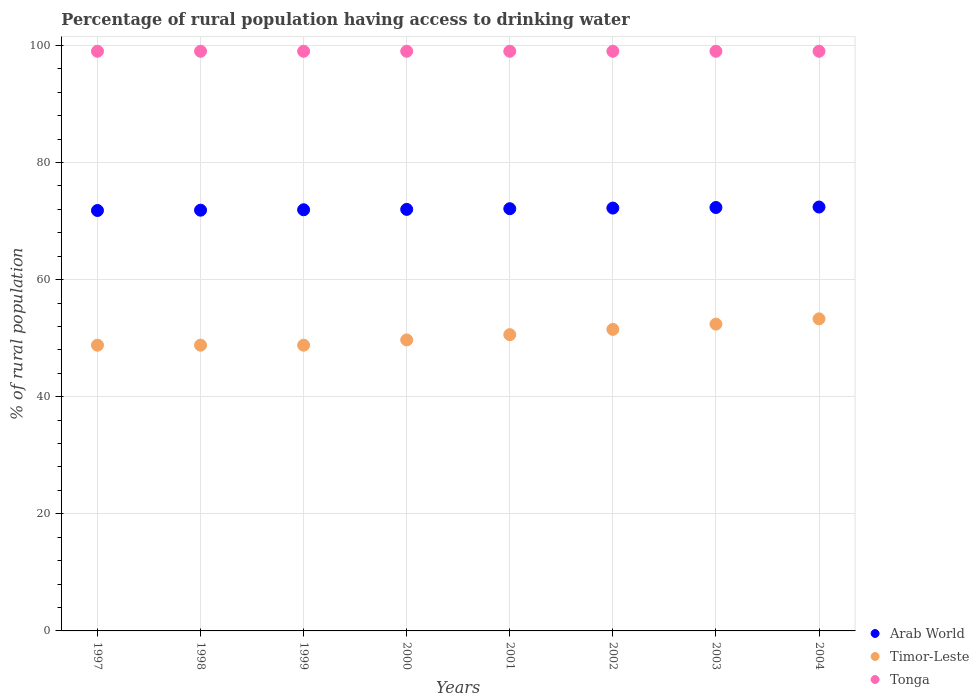What is the percentage of rural population having access to drinking water in Tonga in 2004?
Make the answer very short. 99. Across all years, what is the maximum percentage of rural population having access to drinking water in Arab World?
Ensure brevity in your answer.  72.4. Across all years, what is the minimum percentage of rural population having access to drinking water in Arab World?
Your answer should be very brief. 71.81. What is the total percentage of rural population having access to drinking water in Timor-Leste in the graph?
Keep it short and to the point. 403.9. What is the difference between the percentage of rural population having access to drinking water in Timor-Leste in 1997 and that in 2003?
Your answer should be compact. -3.6. What is the difference between the percentage of rural population having access to drinking water in Timor-Leste in 2004 and the percentage of rural population having access to drinking water in Arab World in 2001?
Provide a succinct answer. -18.81. What is the average percentage of rural population having access to drinking water in Timor-Leste per year?
Offer a terse response. 50.49. In the year 1998, what is the difference between the percentage of rural population having access to drinking water in Timor-Leste and percentage of rural population having access to drinking water in Arab World?
Make the answer very short. -23.06. What is the ratio of the percentage of rural population having access to drinking water in Arab World in 2000 to that in 2003?
Your answer should be compact. 1. Is the percentage of rural population having access to drinking water in Arab World in 2002 less than that in 2004?
Provide a succinct answer. Yes. What is the difference between the highest and the second highest percentage of rural population having access to drinking water in Timor-Leste?
Ensure brevity in your answer.  0.9. What is the difference between the highest and the lowest percentage of rural population having access to drinking water in Arab World?
Make the answer very short. 0.59. In how many years, is the percentage of rural population having access to drinking water in Timor-Leste greater than the average percentage of rural population having access to drinking water in Timor-Leste taken over all years?
Make the answer very short. 4. Is the percentage of rural population having access to drinking water in Tonga strictly greater than the percentage of rural population having access to drinking water in Timor-Leste over the years?
Your answer should be compact. Yes. How many dotlines are there?
Keep it short and to the point. 3. What is the difference between two consecutive major ticks on the Y-axis?
Give a very brief answer. 20. Are the values on the major ticks of Y-axis written in scientific E-notation?
Your answer should be very brief. No. Does the graph contain any zero values?
Your answer should be compact. No. What is the title of the graph?
Offer a very short reply. Percentage of rural population having access to drinking water. What is the label or title of the Y-axis?
Offer a very short reply. % of rural population. What is the % of rural population in Arab World in 1997?
Your answer should be compact. 71.81. What is the % of rural population of Timor-Leste in 1997?
Your answer should be compact. 48.8. What is the % of rural population in Arab World in 1998?
Keep it short and to the point. 71.86. What is the % of rural population of Timor-Leste in 1998?
Your answer should be very brief. 48.8. What is the % of rural population in Tonga in 1998?
Your response must be concise. 99. What is the % of rural population of Arab World in 1999?
Provide a succinct answer. 71.93. What is the % of rural population of Timor-Leste in 1999?
Offer a terse response. 48.8. What is the % of rural population in Tonga in 1999?
Give a very brief answer. 99. What is the % of rural population in Arab World in 2000?
Your answer should be compact. 72. What is the % of rural population of Timor-Leste in 2000?
Keep it short and to the point. 49.7. What is the % of rural population of Arab World in 2001?
Your response must be concise. 72.11. What is the % of rural population in Timor-Leste in 2001?
Keep it short and to the point. 50.6. What is the % of rural population in Tonga in 2001?
Ensure brevity in your answer.  99. What is the % of rural population of Arab World in 2002?
Offer a very short reply. 72.22. What is the % of rural population of Timor-Leste in 2002?
Your response must be concise. 51.5. What is the % of rural population of Arab World in 2003?
Offer a terse response. 72.32. What is the % of rural population of Timor-Leste in 2003?
Give a very brief answer. 52.4. What is the % of rural population of Arab World in 2004?
Offer a terse response. 72.4. What is the % of rural population in Timor-Leste in 2004?
Your answer should be very brief. 53.3. What is the % of rural population of Tonga in 2004?
Make the answer very short. 99. Across all years, what is the maximum % of rural population in Arab World?
Ensure brevity in your answer.  72.4. Across all years, what is the maximum % of rural population of Timor-Leste?
Provide a succinct answer. 53.3. Across all years, what is the minimum % of rural population in Arab World?
Ensure brevity in your answer.  71.81. Across all years, what is the minimum % of rural population of Timor-Leste?
Your answer should be compact. 48.8. What is the total % of rural population of Arab World in the graph?
Ensure brevity in your answer.  576.64. What is the total % of rural population of Timor-Leste in the graph?
Your response must be concise. 403.9. What is the total % of rural population in Tonga in the graph?
Offer a very short reply. 792. What is the difference between the % of rural population in Arab World in 1997 and that in 1998?
Your response must be concise. -0.05. What is the difference between the % of rural population in Tonga in 1997 and that in 1998?
Keep it short and to the point. 0. What is the difference between the % of rural population in Arab World in 1997 and that in 1999?
Provide a succinct answer. -0.12. What is the difference between the % of rural population in Arab World in 1997 and that in 2000?
Give a very brief answer. -0.19. What is the difference between the % of rural population in Timor-Leste in 1997 and that in 2000?
Make the answer very short. -0.9. What is the difference between the % of rural population of Tonga in 1997 and that in 2000?
Offer a terse response. 0. What is the difference between the % of rural population of Arab World in 1997 and that in 2001?
Offer a very short reply. -0.31. What is the difference between the % of rural population of Tonga in 1997 and that in 2001?
Offer a terse response. 0. What is the difference between the % of rural population of Arab World in 1997 and that in 2002?
Your answer should be very brief. -0.42. What is the difference between the % of rural population in Timor-Leste in 1997 and that in 2002?
Make the answer very short. -2.7. What is the difference between the % of rural population of Tonga in 1997 and that in 2002?
Provide a short and direct response. 0. What is the difference between the % of rural population of Arab World in 1997 and that in 2003?
Give a very brief answer. -0.51. What is the difference between the % of rural population in Timor-Leste in 1997 and that in 2003?
Provide a succinct answer. -3.6. What is the difference between the % of rural population in Arab World in 1997 and that in 2004?
Provide a short and direct response. -0.59. What is the difference between the % of rural population in Timor-Leste in 1997 and that in 2004?
Make the answer very short. -4.5. What is the difference between the % of rural population in Tonga in 1997 and that in 2004?
Make the answer very short. 0. What is the difference between the % of rural population in Arab World in 1998 and that in 1999?
Provide a succinct answer. -0.07. What is the difference between the % of rural population of Tonga in 1998 and that in 1999?
Offer a very short reply. 0. What is the difference between the % of rural population in Arab World in 1998 and that in 2000?
Your response must be concise. -0.14. What is the difference between the % of rural population in Tonga in 1998 and that in 2000?
Give a very brief answer. 0. What is the difference between the % of rural population in Arab World in 1998 and that in 2001?
Give a very brief answer. -0.25. What is the difference between the % of rural population of Timor-Leste in 1998 and that in 2001?
Provide a short and direct response. -1.8. What is the difference between the % of rural population of Tonga in 1998 and that in 2001?
Ensure brevity in your answer.  0. What is the difference between the % of rural population of Arab World in 1998 and that in 2002?
Offer a terse response. -0.36. What is the difference between the % of rural population in Arab World in 1998 and that in 2003?
Make the answer very short. -0.46. What is the difference between the % of rural population in Timor-Leste in 1998 and that in 2003?
Offer a very short reply. -3.6. What is the difference between the % of rural population of Arab World in 1998 and that in 2004?
Your answer should be very brief. -0.54. What is the difference between the % of rural population of Tonga in 1998 and that in 2004?
Offer a very short reply. 0. What is the difference between the % of rural population of Arab World in 1999 and that in 2000?
Your answer should be compact. -0.07. What is the difference between the % of rural population in Timor-Leste in 1999 and that in 2000?
Your response must be concise. -0.9. What is the difference between the % of rural population of Arab World in 1999 and that in 2001?
Your answer should be compact. -0.18. What is the difference between the % of rural population of Timor-Leste in 1999 and that in 2001?
Offer a terse response. -1.8. What is the difference between the % of rural population in Tonga in 1999 and that in 2001?
Your response must be concise. 0. What is the difference between the % of rural population in Arab World in 1999 and that in 2002?
Provide a short and direct response. -0.29. What is the difference between the % of rural population of Arab World in 1999 and that in 2003?
Your answer should be compact. -0.39. What is the difference between the % of rural population of Timor-Leste in 1999 and that in 2003?
Your response must be concise. -3.6. What is the difference between the % of rural population in Arab World in 1999 and that in 2004?
Ensure brevity in your answer.  -0.47. What is the difference between the % of rural population of Arab World in 2000 and that in 2001?
Provide a succinct answer. -0.12. What is the difference between the % of rural population in Tonga in 2000 and that in 2001?
Your answer should be compact. 0. What is the difference between the % of rural population in Arab World in 2000 and that in 2002?
Offer a terse response. -0.23. What is the difference between the % of rural population of Tonga in 2000 and that in 2002?
Your answer should be very brief. 0. What is the difference between the % of rural population of Arab World in 2000 and that in 2003?
Keep it short and to the point. -0.32. What is the difference between the % of rural population of Timor-Leste in 2000 and that in 2003?
Your answer should be compact. -2.7. What is the difference between the % of rural population of Tonga in 2000 and that in 2003?
Your response must be concise. 0. What is the difference between the % of rural population of Arab World in 2000 and that in 2004?
Offer a terse response. -0.4. What is the difference between the % of rural population in Timor-Leste in 2000 and that in 2004?
Provide a short and direct response. -3.6. What is the difference between the % of rural population in Arab World in 2001 and that in 2002?
Your response must be concise. -0.11. What is the difference between the % of rural population in Timor-Leste in 2001 and that in 2002?
Give a very brief answer. -0.9. What is the difference between the % of rural population of Arab World in 2001 and that in 2003?
Your response must be concise. -0.21. What is the difference between the % of rural population of Timor-Leste in 2001 and that in 2003?
Keep it short and to the point. -1.8. What is the difference between the % of rural population of Tonga in 2001 and that in 2003?
Keep it short and to the point. 0. What is the difference between the % of rural population in Arab World in 2001 and that in 2004?
Your answer should be compact. -0.29. What is the difference between the % of rural population in Timor-Leste in 2001 and that in 2004?
Give a very brief answer. -2.7. What is the difference between the % of rural population in Arab World in 2002 and that in 2003?
Offer a very short reply. -0.1. What is the difference between the % of rural population of Timor-Leste in 2002 and that in 2003?
Make the answer very short. -0.9. What is the difference between the % of rural population of Arab World in 2002 and that in 2004?
Offer a terse response. -0.18. What is the difference between the % of rural population in Timor-Leste in 2002 and that in 2004?
Your answer should be very brief. -1.8. What is the difference between the % of rural population in Arab World in 2003 and that in 2004?
Give a very brief answer. -0.08. What is the difference between the % of rural population of Timor-Leste in 2003 and that in 2004?
Offer a very short reply. -0.9. What is the difference between the % of rural population in Arab World in 1997 and the % of rural population in Timor-Leste in 1998?
Your answer should be compact. 23.01. What is the difference between the % of rural population in Arab World in 1997 and the % of rural population in Tonga in 1998?
Your answer should be compact. -27.19. What is the difference between the % of rural population of Timor-Leste in 1997 and the % of rural population of Tonga in 1998?
Keep it short and to the point. -50.2. What is the difference between the % of rural population of Arab World in 1997 and the % of rural population of Timor-Leste in 1999?
Ensure brevity in your answer.  23.01. What is the difference between the % of rural population of Arab World in 1997 and the % of rural population of Tonga in 1999?
Your answer should be very brief. -27.19. What is the difference between the % of rural population of Timor-Leste in 1997 and the % of rural population of Tonga in 1999?
Give a very brief answer. -50.2. What is the difference between the % of rural population of Arab World in 1997 and the % of rural population of Timor-Leste in 2000?
Your answer should be compact. 22.11. What is the difference between the % of rural population in Arab World in 1997 and the % of rural population in Tonga in 2000?
Your response must be concise. -27.19. What is the difference between the % of rural population of Timor-Leste in 1997 and the % of rural population of Tonga in 2000?
Give a very brief answer. -50.2. What is the difference between the % of rural population in Arab World in 1997 and the % of rural population in Timor-Leste in 2001?
Provide a short and direct response. 21.21. What is the difference between the % of rural population of Arab World in 1997 and the % of rural population of Tonga in 2001?
Offer a very short reply. -27.19. What is the difference between the % of rural population in Timor-Leste in 1997 and the % of rural population in Tonga in 2001?
Make the answer very short. -50.2. What is the difference between the % of rural population in Arab World in 1997 and the % of rural population in Timor-Leste in 2002?
Provide a short and direct response. 20.31. What is the difference between the % of rural population of Arab World in 1997 and the % of rural population of Tonga in 2002?
Keep it short and to the point. -27.19. What is the difference between the % of rural population of Timor-Leste in 1997 and the % of rural population of Tonga in 2002?
Your response must be concise. -50.2. What is the difference between the % of rural population of Arab World in 1997 and the % of rural population of Timor-Leste in 2003?
Offer a very short reply. 19.41. What is the difference between the % of rural population of Arab World in 1997 and the % of rural population of Tonga in 2003?
Keep it short and to the point. -27.19. What is the difference between the % of rural population in Timor-Leste in 1997 and the % of rural population in Tonga in 2003?
Offer a terse response. -50.2. What is the difference between the % of rural population of Arab World in 1997 and the % of rural population of Timor-Leste in 2004?
Give a very brief answer. 18.51. What is the difference between the % of rural population in Arab World in 1997 and the % of rural population in Tonga in 2004?
Offer a very short reply. -27.19. What is the difference between the % of rural population in Timor-Leste in 1997 and the % of rural population in Tonga in 2004?
Your answer should be compact. -50.2. What is the difference between the % of rural population of Arab World in 1998 and the % of rural population of Timor-Leste in 1999?
Provide a short and direct response. 23.06. What is the difference between the % of rural population of Arab World in 1998 and the % of rural population of Tonga in 1999?
Your answer should be compact. -27.14. What is the difference between the % of rural population of Timor-Leste in 1998 and the % of rural population of Tonga in 1999?
Provide a succinct answer. -50.2. What is the difference between the % of rural population of Arab World in 1998 and the % of rural population of Timor-Leste in 2000?
Your answer should be very brief. 22.16. What is the difference between the % of rural population in Arab World in 1998 and the % of rural population in Tonga in 2000?
Give a very brief answer. -27.14. What is the difference between the % of rural population of Timor-Leste in 1998 and the % of rural population of Tonga in 2000?
Provide a succinct answer. -50.2. What is the difference between the % of rural population in Arab World in 1998 and the % of rural population in Timor-Leste in 2001?
Ensure brevity in your answer.  21.26. What is the difference between the % of rural population in Arab World in 1998 and the % of rural population in Tonga in 2001?
Ensure brevity in your answer.  -27.14. What is the difference between the % of rural population in Timor-Leste in 1998 and the % of rural population in Tonga in 2001?
Ensure brevity in your answer.  -50.2. What is the difference between the % of rural population of Arab World in 1998 and the % of rural population of Timor-Leste in 2002?
Ensure brevity in your answer.  20.36. What is the difference between the % of rural population of Arab World in 1998 and the % of rural population of Tonga in 2002?
Offer a terse response. -27.14. What is the difference between the % of rural population in Timor-Leste in 1998 and the % of rural population in Tonga in 2002?
Your response must be concise. -50.2. What is the difference between the % of rural population in Arab World in 1998 and the % of rural population in Timor-Leste in 2003?
Your answer should be very brief. 19.46. What is the difference between the % of rural population in Arab World in 1998 and the % of rural population in Tonga in 2003?
Provide a short and direct response. -27.14. What is the difference between the % of rural population of Timor-Leste in 1998 and the % of rural population of Tonga in 2003?
Provide a short and direct response. -50.2. What is the difference between the % of rural population in Arab World in 1998 and the % of rural population in Timor-Leste in 2004?
Provide a succinct answer. 18.56. What is the difference between the % of rural population in Arab World in 1998 and the % of rural population in Tonga in 2004?
Offer a terse response. -27.14. What is the difference between the % of rural population in Timor-Leste in 1998 and the % of rural population in Tonga in 2004?
Provide a succinct answer. -50.2. What is the difference between the % of rural population of Arab World in 1999 and the % of rural population of Timor-Leste in 2000?
Make the answer very short. 22.23. What is the difference between the % of rural population in Arab World in 1999 and the % of rural population in Tonga in 2000?
Make the answer very short. -27.07. What is the difference between the % of rural population in Timor-Leste in 1999 and the % of rural population in Tonga in 2000?
Provide a short and direct response. -50.2. What is the difference between the % of rural population of Arab World in 1999 and the % of rural population of Timor-Leste in 2001?
Keep it short and to the point. 21.33. What is the difference between the % of rural population of Arab World in 1999 and the % of rural population of Tonga in 2001?
Make the answer very short. -27.07. What is the difference between the % of rural population in Timor-Leste in 1999 and the % of rural population in Tonga in 2001?
Offer a terse response. -50.2. What is the difference between the % of rural population in Arab World in 1999 and the % of rural population in Timor-Leste in 2002?
Your response must be concise. 20.43. What is the difference between the % of rural population of Arab World in 1999 and the % of rural population of Tonga in 2002?
Provide a short and direct response. -27.07. What is the difference between the % of rural population of Timor-Leste in 1999 and the % of rural population of Tonga in 2002?
Offer a very short reply. -50.2. What is the difference between the % of rural population of Arab World in 1999 and the % of rural population of Timor-Leste in 2003?
Offer a terse response. 19.53. What is the difference between the % of rural population in Arab World in 1999 and the % of rural population in Tonga in 2003?
Make the answer very short. -27.07. What is the difference between the % of rural population of Timor-Leste in 1999 and the % of rural population of Tonga in 2003?
Your answer should be compact. -50.2. What is the difference between the % of rural population of Arab World in 1999 and the % of rural population of Timor-Leste in 2004?
Your response must be concise. 18.63. What is the difference between the % of rural population of Arab World in 1999 and the % of rural population of Tonga in 2004?
Your response must be concise. -27.07. What is the difference between the % of rural population of Timor-Leste in 1999 and the % of rural population of Tonga in 2004?
Give a very brief answer. -50.2. What is the difference between the % of rural population in Arab World in 2000 and the % of rural population in Timor-Leste in 2001?
Offer a very short reply. 21.4. What is the difference between the % of rural population of Arab World in 2000 and the % of rural population of Tonga in 2001?
Ensure brevity in your answer.  -27. What is the difference between the % of rural population in Timor-Leste in 2000 and the % of rural population in Tonga in 2001?
Make the answer very short. -49.3. What is the difference between the % of rural population of Arab World in 2000 and the % of rural population of Timor-Leste in 2002?
Offer a terse response. 20.5. What is the difference between the % of rural population of Arab World in 2000 and the % of rural population of Tonga in 2002?
Make the answer very short. -27. What is the difference between the % of rural population of Timor-Leste in 2000 and the % of rural population of Tonga in 2002?
Offer a terse response. -49.3. What is the difference between the % of rural population in Arab World in 2000 and the % of rural population in Timor-Leste in 2003?
Keep it short and to the point. 19.6. What is the difference between the % of rural population of Arab World in 2000 and the % of rural population of Tonga in 2003?
Your response must be concise. -27. What is the difference between the % of rural population of Timor-Leste in 2000 and the % of rural population of Tonga in 2003?
Your response must be concise. -49.3. What is the difference between the % of rural population in Arab World in 2000 and the % of rural population in Timor-Leste in 2004?
Make the answer very short. 18.7. What is the difference between the % of rural population in Arab World in 2000 and the % of rural population in Tonga in 2004?
Ensure brevity in your answer.  -27. What is the difference between the % of rural population in Timor-Leste in 2000 and the % of rural population in Tonga in 2004?
Offer a very short reply. -49.3. What is the difference between the % of rural population of Arab World in 2001 and the % of rural population of Timor-Leste in 2002?
Give a very brief answer. 20.61. What is the difference between the % of rural population of Arab World in 2001 and the % of rural population of Tonga in 2002?
Keep it short and to the point. -26.89. What is the difference between the % of rural population in Timor-Leste in 2001 and the % of rural population in Tonga in 2002?
Offer a terse response. -48.4. What is the difference between the % of rural population of Arab World in 2001 and the % of rural population of Timor-Leste in 2003?
Keep it short and to the point. 19.71. What is the difference between the % of rural population of Arab World in 2001 and the % of rural population of Tonga in 2003?
Provide a short and direct response. -26.89. What is the difference between the % of rural population in Timor-Leste in 2001 and the % of rural population in Tonga in 2003?
Your answer should be compact. -48.4. What is the difference between the % of rural population in Arab World in 2001 and the % of rural population in Timor-Leste in 2004?
Offer a very short reply. 18.81. What is the difference between the % of rural population in Arab World in 2001 and the % of rural population in Tonga in 2004?
Ensure brevity in your answer.  -26.89. What is the difference between the % of rural population in Timor-Leste in 2001 and the % of rural population in Tonga in 2004?
Your answer should be compact. -48.4. What is the difference between the % of rural population of Arab World in 2002 and the % of rural population of Timor-Leste in 2003?
Give a very brief answer. 19.82. What is the difference between the % of rural population of Arab World in 2002 and the % of rural population of Tonga in 2003?
Keep it short and to the point. -26.78. What is the difference between the % of rural population of Timor-Leste in 2002 and the % of rural population of Tonga in 2003?
Make the answer very short. -47.5. What is the difference between the % of rural population in Arab World in 2002 and the % of rural population in Timor-Leste in 2004?
Offer a very short reply. 18.92. What is the difference between the % of rural population in Arab World in 2002 and the % of rural population in Tonga in 2004?
Keep it short and to the point. -26.78. What is the difference between the % of rural population of Timor-Leste in 2002 and the % of rural population of Tonga in 2004?
Offer a terse response. -47.5. What is the difference between the % of rural population of Arab World in 2003 and the % of rural population of Timor-Leste in 2004?
Offer a very short reply. 19.02. What is the difference between the % of rural population in Arab World in 2003 and the % of rural population in Tonga in 2004?
Your response must be concise. -26.68. What is the difference between the % of rural population of Timor-Leste in 2003 and the % of rural population of Tonga in 2004?
Give a very brief answer. -46.6. What is the average % of rural population of Arab World per year?
Make the answer very short. 72.08. What is the average % of rural population in Timor-Leste per year?
Your answer should be compact. 50.49. In the year 1997, what is the difference between the % of rural population of Arab World and % of rural population of Timor-Leste?
Your answer should be very brief. 23.01. In the year 1997, what is the difference between the % of rural population in Arab World and % of rural population in Tonga?
Keep it short and to the point. -27.19. In the year 1997, what is the difference between the % of rural population in Timor-Leste and % of rural population in Tonga?
Your answer should be compact. -50.2. In the year 1998, what is the difference between the % of rural population of Arab World and % of rural population of Timor-Leste?
Keep it short and to the point. 23.06. In the year 1998, what is the difference between the % of rural population of Arab World and % of rural population of Tonga?
Make the answer very short. -27.14. In the year 1998, what is the difference between the % of rural population in Timor-Leste and % of rural population in Tonga?
Keep it short and to the point. -50.2. In the year 1999, what is the difference between the % of rural population in Arab World and % of rural population in Timor-Leste?
Offer a very short reply. 23.13. In the year 1999, what is the difference between the % of rural population in Arab World and % of rural population in Tonga?
Give a very brief answer. -27.07. In the year 1999, what is the difference between the % of rural population of Timor-Leste and % of rural population of Tonga?
Make the answer very short. -50.2. In the year 2000, what is the difference between the % of rural population of Arab World and % of rural population of Timor-Leste?
Keep it short and to the point. 22.3. In the year 2000, what is the difference between the % of rural population in Arab World and % of rural population in Tonga?
Provide a short and direct response. -27. In the year 2000, what is the difference between the % of rural population in Timor-Leste and % of rural population in Tonga?
Offer a terse response. -49.3. In the year 2001, what is the difference between the % of rural population of Arab World and % of rural population of Timor-Leste?
Offer a terse response. 21.51. In the year 2001, what is the difference between the % of rural population in Arab World and % of rural population in Tonga?
Provide a succinct answer. -26.89. In the year 2001, what is the difference between the % of rural population of Timor-Leste and % of rural population of Tonga?
Offer a terse response. -48.4. In the year 2002, what is the difference between the % of rural population in Arab World and % of rural population in Timor-Leste?
Give a very brief answer. 20.72. In the year 2002, what is the difference between the % of rural population of Arab World and % of rural population of Tonga?
Your answer should be very brief. -26.78. In the year 2002, what is the difference between the % of rural population of Timor-Leste and % of rural population of Tonga?
Provide a short and direct response. -47.5. In the year 2003, what is the difference between the % of rural population in Arab World and % of rural population in Timor-Leste?
Your response must be concise. 19.92. In the year 2003, what is the difference between the % of rural population in Arab World and % of rural population in Tonga?
Keep it short and to the point. -26.68. In the year 2003, what is the difference between the % of rural population of Timor-Leste and % of rural population of Tonga?
Offer a terse response. -46.6. In the year 2004, what is the difference between the % of rural population of Arab World and % of rural population of Timor-Leste?
Offer a terse response. 19.1. In the year 2004, what is the difference between the % of rural population in Arab World and % of rural population in Tonga?
Ensure brevity in your answer.  -26.6. In the year 2004, what is the difference between the % of rural population in Timor-Leste and % of rural population in Tonga?
Make the answer very short. -45.7. What is the ratio of the % of rural population in Arab World in 1997 to that in 1998?
Your response must be concise. 1. What is the ratio of the % of rural population of Timor-Leste in 1997 to that in 1998?
Give a very brief answer. 1. What is the ratio of the % of rural population of Timor-Leste in 1997 to that in 1999?
Make the answer very short. 1. What is the ratio of the % of rural population of Timor-Leste in 1997 to that in 2000?
Your answer should be very brief. 0.98. What is the ratio of the % of rural population of Timor-Leste in 1997 to that in 2001?
Your answer should be very brief. 0.96. What is the ratio of the % of rural population of Tonga in 1997 to that in 2001?
Your response must be concise. 1. What is the ratio of the % of rural population in Arab World in 1997 to that in 2002?
Your response must be concise. 0.99. What is the ratio of the % of rural population in Timor-Leste in 1997 to that in 2002?
Provide a succinct answer. 0.95. What is the ratio of the % of rural population of Arab World in 1997 to that in 2003?
Your answer should be very brief. 0.99. What is the ratio of the % of rural population in Timor-Leste in 1997 to that in 2003?
Ensure brevity in your answer.  0.93. What is the ratio of the % of rural population of Tonga in 1997 to that in 2003?
Provide a short and direct response. 1. What is the ratio of the % of rural population in Arab World in 1997 to that in 2004?
Make the answer very short. 0.99. What is the ratio of the % of rural population of Timor-Leste in 1997 to that in 2004?
Keep it short and to the point. 0.92. What is the ratio of the % of rural population in Arab World in 1998 to that in 1999?
Give a very brief answer. 1. What is the ratio of the % of rural population of Timor-Leste in 1998 to that in 1999?
Provide a succinct answer. 1. What is the ratio of the % of rural population of Timor-Leste in 1998 to that in 2000?
Keep it short and to the point. 0.98. What is the ratio of the % of rural population in Timor-Leste in 1998 to that in 2001?
Ensure brevity in your answer.  0.96. What is the ratio of the % of rural population of Tonga in 1998 to that in 2001?
Offer a terse response. 1. What is the ratio of the % of rural population of Timor-Leste in 1998 to that in 2002?
Keep it short and to the point. 0.95. What is the ratio of the % of rural population of Tonga in 1998 to that in 2002?
Your response must be concise. 1. What is the ratio of the % of rural population in Arab World in 1998 to that in 2003?
Give a very brief answer. 0.99. What is the ratio of the % of rural population in Timor-Leste in 1998 to that in 2003?
Your answer should be very brief. 0.93. What is the ratio of the % of rural population in Tonga in 1998 to that in 2003?
Give a very brief answer. 1. What is the ratio of the % of rural population in Arab World in 1998 to that in 2004?
Your answer should be compact. 0.99. What is the ratio of the % of rural population in Timor-Leste in 1998 to that in 2004?
Provide a succinct answer. 0.92. What is the ratio of the % of rural population of Tonga in 1998 to that in 2004?
Ensure brevity in your answer.  1. What is the ratio of the % of rural population in Timor-Leste in 1999 to that in 2000?
Keep it short and to the point. 0.98. What is the ratio of the % of rural population in Timor-Leste in 1999 to that in 2001?
Keep it short and to the point. 0.96. What is the ratio of the % of rural population in Timor-Leste in 1999 to that in 2002?
Provide a short and direct response. 0.95. What is the ratio of the % of rural population of Tonga in 1999 to that in 2002?
Keep it short and to the point. 1. What is the ratio of the % of rural population in Arab World in 1999 to that in 2003?
Make the answer very short. 0.99. What is the ratio of the % of rural population of Timor-Leste in 1999 to that in 2003?
Your response must be concise. 0.93. What is the ratio of the % of rural population of Tonga in 1999 to that in 2003?
Give a very brief answer. 1. What is the ratio of the % of rural population of Arab World in 1999 to that in 2004?
Make the answer very short. 0.99. What is the ratio of the % of rural population of Timor-Leste in 1999 to that in 2004?
Your answer should be compact. 0.92. What is the ratio of the % of rural population in Tonga in 1999 to that in 2004?
Your response must be concise. 1. What is the ratio of the % of rural population of Arab World in 2000 to that in 2001?
Ensure brevity in your answer.  1. What is the ratio of the % of rural population in Timor-Leste in 2000 to that in 2001?
Your answer should be very brief. 0.98. What is the ratio of the % of rural population of Arab World in 2000 to that in 2002?
Your answer should be very brief. 1. What is the ratio of the % of rural population of Tonga in 2000 to that in 2002?
Offer a terse response. 1. What is the ratio of the % of rural population of Arab World in 2000 to that in 2003?
Keep it short and to the point. 1. What is the ratio of the % of rural population in Timor-Leste in 2000 to that in 2003?
Your answer should be very brief. 0.95. What is the ratio of the % of rural population of Arab World in 2000 to that in 2004?
Your answer should be very brief. 0.99. What is the ratio of the % of rural population of Timor-Leste in 2000 to that in 2004?
Ensure brevity in your answer.  0.93. What is the ratio of the % of rural population of Tonga in 2000 to that in 2004?
Provide a succinct answer. 1. What is the ratio of the % of rural population in Timor-Leste in 2001 to that in 2002?
Your answer should be very brief. 0.98. What is the ratio of the % of rural population in Arab World in 2001 to that in 2003?
Provide a short and direct response. 1. What is the ratio of the % of rural population of Timor-Leste in 2001 to that in 2003?
Keep it short and to the point. 0.97. What is the ratio of the % of rural population in Arab World in 2001 to that in 2004?
Keep it short and to the point. 1. What is the ratio of the % of rural population in Timor-Leste in 2001 to that in 2004?
Offer a terse response. 0.95. What is the ratio of the % of rural population of Timor-Leste in 2002 to that in 2003?
Offer a terse response. 0.98. What is the ratio of the % of rural population in Tonga in 2002 to that in 2003?
Ensure brevity in your answer.  1. What is the ratio of the % of rural population in Arab World in 2002 to that in 2004?
Your answer should be compact. 1. What is the ratio of the % of rural population in Timor-Leste in 2002 to that in 2004?
Offer a terse response. 0.97. What is the ratio of the % of rural population in Tonga in 2002 to that in 2004?
Your response must be concise. 1. What is the ratio of the % of rural population of Arab World in 2003 to that in 2004?
Make the answer very short. 1. What is the ratio of the % of rural population of Timor-Leste in 2003 to that in 2004?
Keep it short and to the point. 0.98. What is the difference between the highest and the second highest % of rural population in Arab World?
Your response must be concise. 0.08. What is the difference between the highest and the lowest % of rural population in Arab World?
Offer a very short reply. 0.59. What is the difference between the highest and the lowest % of rural population of Timor-Leste?
Give a very brief answer. 4.5. What is the difference between the highest and the lowest % of rural population in Tonga?
Offer a very short reply. 0. 